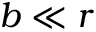<formula> <loc_0><loc_0><loc_500><loc_500>b \ll r</formula> 